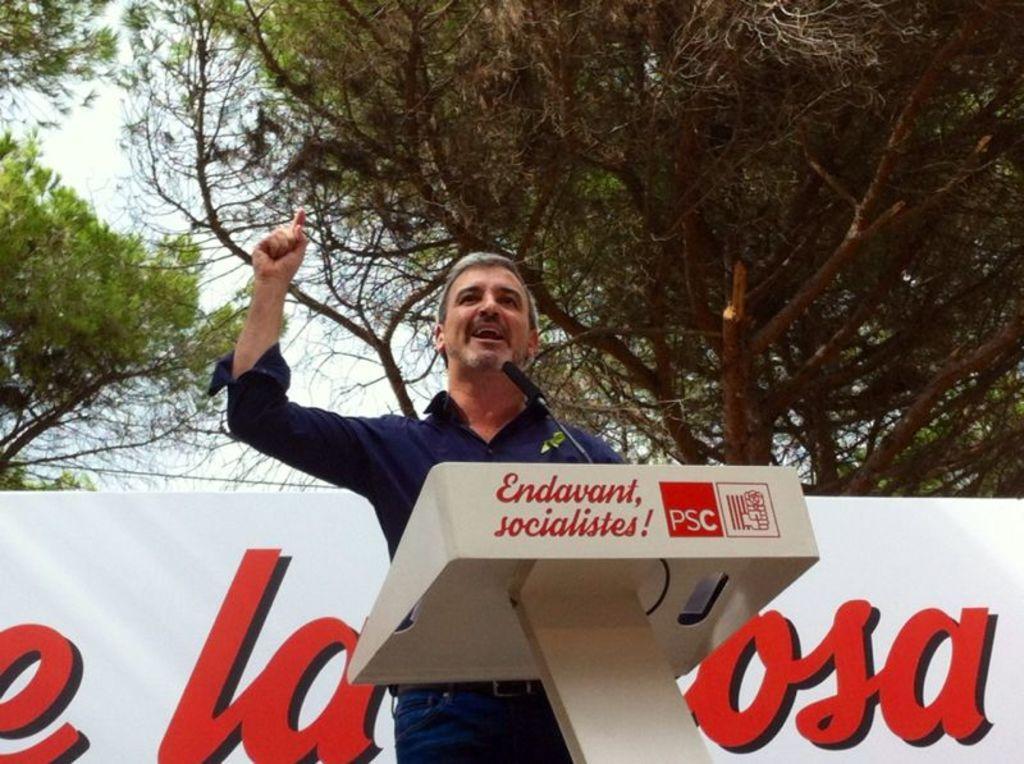Can you describe this image briefly? In this image we can see a person standing in front of the podium, on the podium, we can see a mic, behind the person we can see a poster with some text and trees, in the background we can see the sky. 